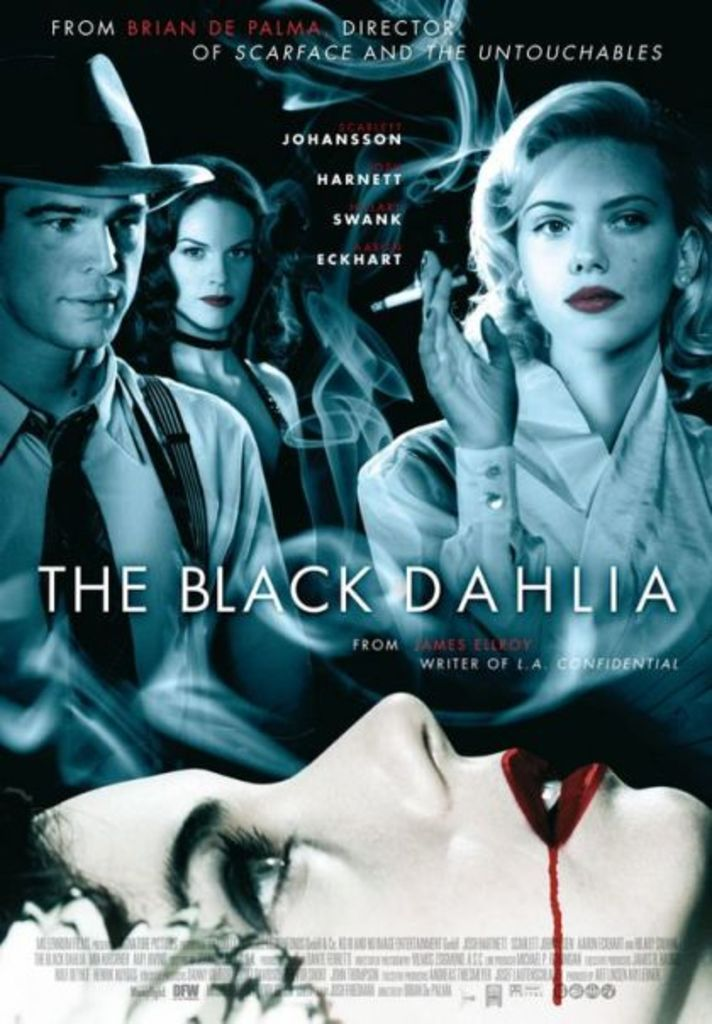What genre does the movie 'The Black Dahlia' belong to, and what can you infer about the tone of the film from the poster? The movie 'The Black Dahlia' is a crime thriller with noir influences. The dark and moody visuals on the poster, combined with facial expressions of the characters, suggest a serious and suspenseful tone consistent with the film's genre. 